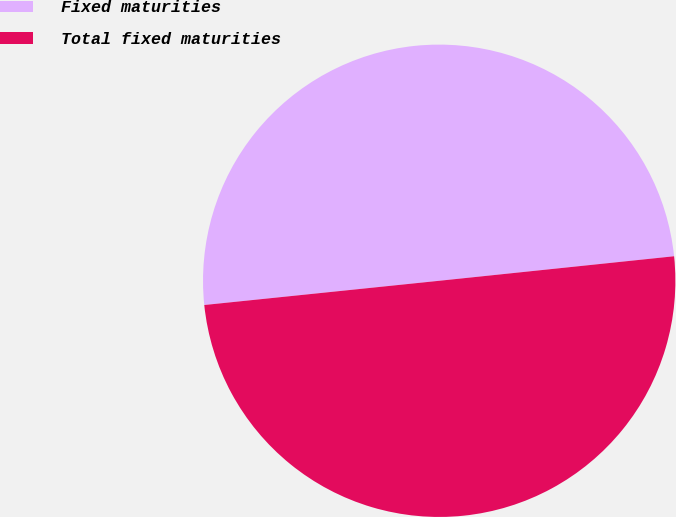Convert chart to OTSL. <chart><loc_0><loc_0><loc_500><loc_500><pie_chart><fcel>Fixed maturities<fcel>Total fixed maturities<nl><fcel>49.98%<fcel>50.02%<nl></chart> 